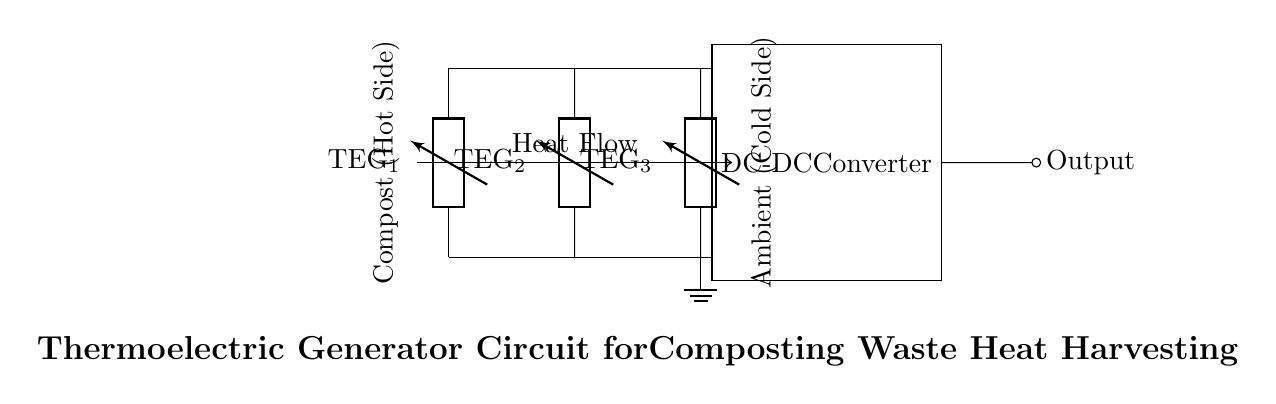What type of components are used in this circuit? The circuit uses thermoelectric generators (TEGs) labeled as TEG_1, TEG_2, and TEG_3. These components are designed to convert thermal energy into electrical energy.
Answer: thermoelectric generators How many thermoelectric generators are present in the circuit? There are three thermoelectric generators indicated in the diagram, which are labeled as TEG_1, TEG_2, and TEG_3.
Answer: three What is the purpose of the DC-DC converter in this circuit? The DC-DC converter adjusts the voltage output from the thermoelectric generators to a desired level suitable for powering electronic devices or systems effectively.
Answer: voltage adjustment Where is the hot side of the composting process depicted in the circuit diagram? The hot side is indicated on the left side of the diagram where it mentions "Compost (Hot Side)," showing that heat is sourced from this area.
Answer: left side What direction does the heat flow in the circuit? The heat flows from the compost (hot area) towards the ambient environment (cold area) as shown by the arrow labeled "Heat Flow."
Answer: right Why is it important to have a cold side in this thermoelectric generator circuit? The cold side creates a temperature difference across the thermoelectric generators, which is essential for them to function effectively and produce electrical power through thermoelectric effects.
Answer: temperature difference 